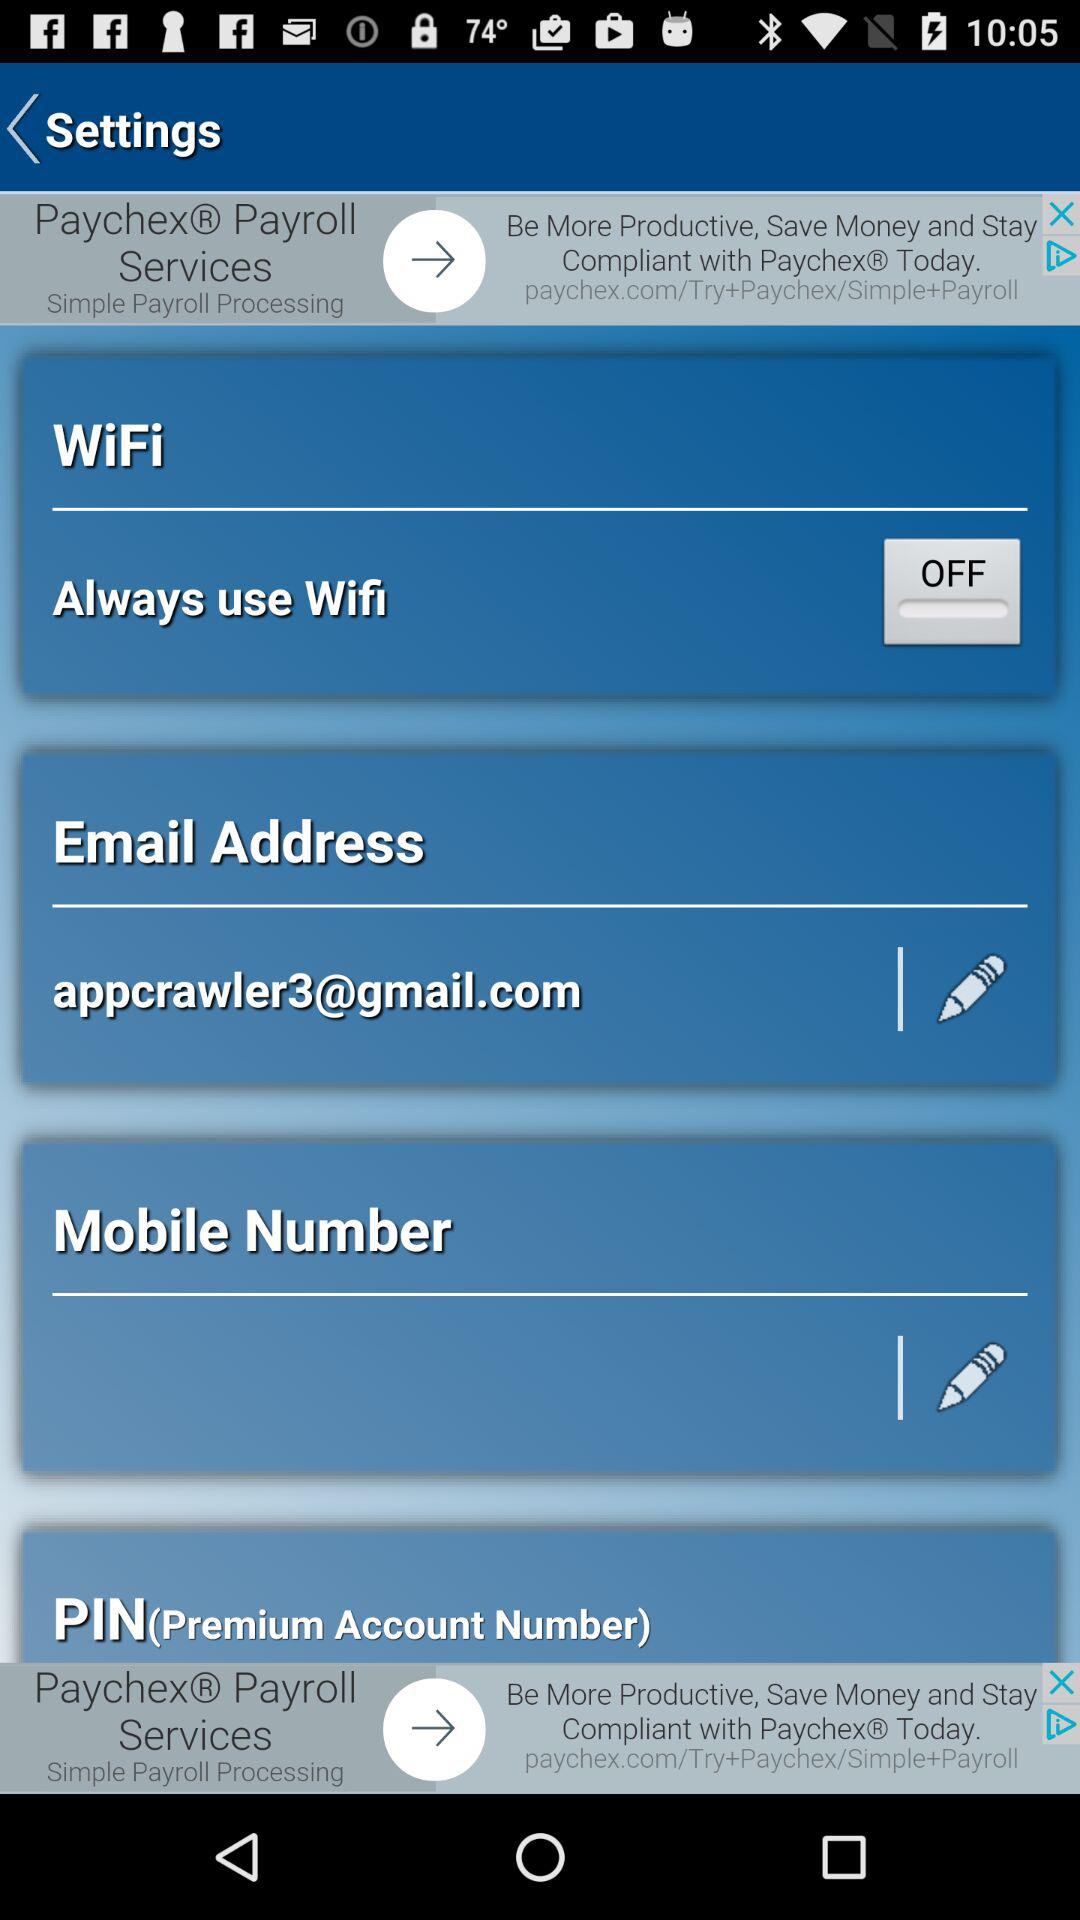What is the email address? The email address is appcrawler3@gmail.com. 